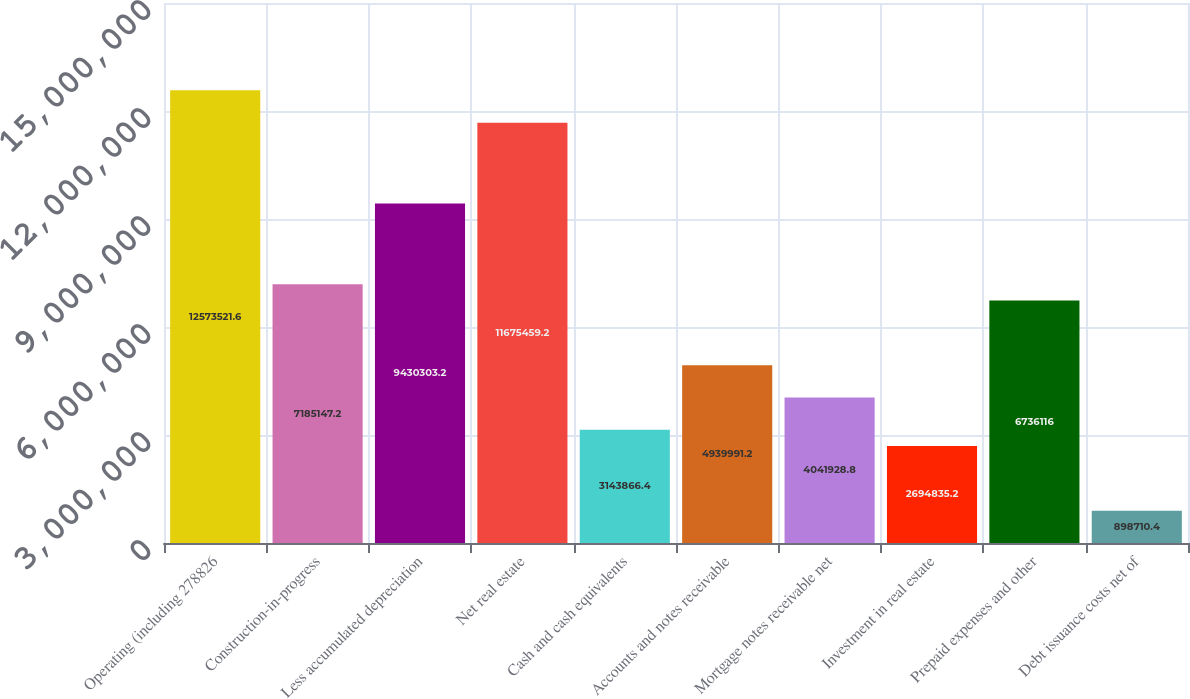<chart> <loc_0><loc_0><loc_500><loc_500><bar_chart><fcel>Operating (including 278826<fcel>Construction-in-progress<fcel>Less accumulated depreciation<fcel>Net real estate<fcel>Cash and cash equivalents<fcel>Accounts and notes receivable<fcel>Mortgage notes receivable net<fcel>Investment in real estate<fcel>Prepaid expenses and other<fcel>Debt issuance costs net of<nl><fcel>1.25735e+07<fcel>7.18515e+06<fcel>9.4303e+06<fcel>1.16755e+07<fcel>3.14387e+06<fcel>4.93999e+06<fcel>4.04193e+06<fcel>2.69484e+06<fcel>6.73612e+06<fcel>898710<nl></chart> 